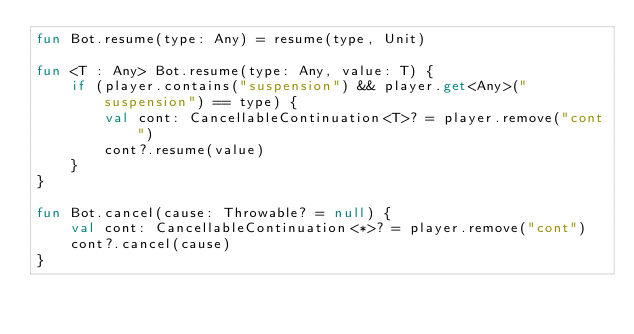Convert code to text. <code><loc_0><loc_0><loc_500><loc_500><_Kotlin_>fun Bot.resume(type: Any) = resume(type, Unit)

fun <T : Any> Bot.resume(type: Any, value: T) {
    if (player.contains("suspension") && player.get<Any>("suspension") == type) {
        val cont: CancellableContinuation<T>? = player.remove("cont")
        cont?.resume(value)
    }
}

fun Bot.cancel(cause: Throwable? = null) {
    val cont: CancellableContinuation<*>? = player.remove("cont")
    cont?.cancel(cause)
}</code> 